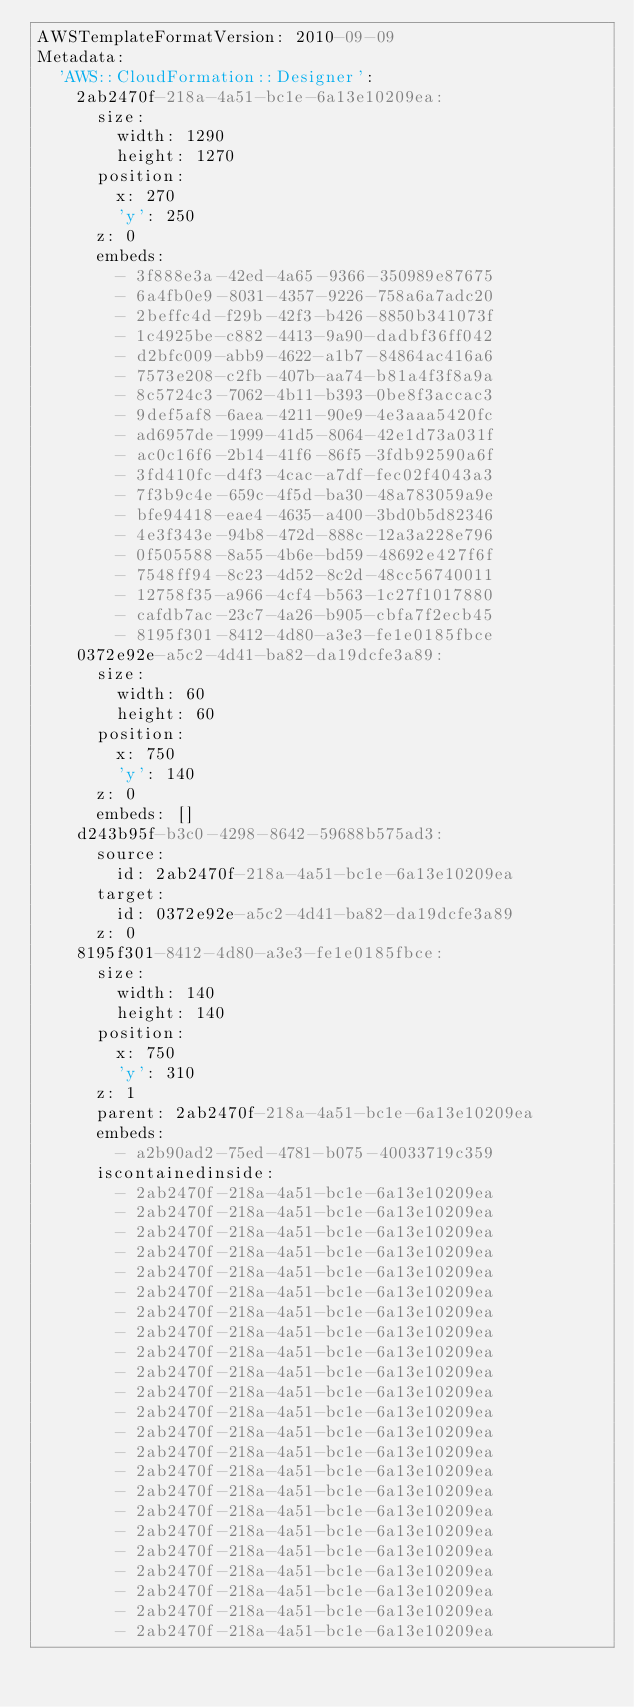Convert code to text. <code><loc_0><loc_0><loc_500><loc_500><_YAML_>AWSTemplateFormatVersion: 2010-09-09
Metadata:
  'AWS::CloudFormation::Designer':
    2ab2470f-218a-4a51-bc1e-6a13e10209ea:
      size:
        width: 1290
        height: 1270
      position:
        x: 270
        'y': 250
      z: 0
      embeds:
        - 3f888e3a-42ed-4a65-9366-350989e87675
        - 6a4fb0e9-8031-4357-9226-758a6a7adc20
        - 2beffc4d-f29b-42f3-b426-8850b341073f
        - 1c4925be-c882-4413-9a90-dadbf36ff042
        - d2bfc009-abb9-4622-a1b7-84864ac416a6
        - 7573e208-c2fb-407b-aa74-b81a4f3f8a9a
        - 8c5724c3-7062-4b11-b393-0be8f3accac3
        - 9def5af8-6aea-4211-90e9-4e3aaa5420fc
        - ad6957de-1999-41d5-8064-42e1d73a031f
        - ac0c16f6-2b14-41f6-86f5-3fdb92590a6f
        - 3fd410fc-d4f3-4cac-a7df-fec02f4043a3
        - 7f3b9c4e-659c-4f5d-ba30-48a783059a9e
        - bfe94418-eae4-4635-a400-3bd0b5d82346
        - 4e3f343e-94b8-472d-888c-12a3a228e796
        - 0f505588-8a55-4b6e-bd59-48692e427f6f
        - 7548ff94-8c23-4d52-8c2d-48cc56740011
        - 12758f35-a966-4cf4-b563-1c27f1017880
        - cafdb7ac-23c7-4a26-b905-cbfa7f2ecb45
        - 8195f301-8412-4d80-a3e3-fe1e0185fbce
    0372e92e-a5c2-4d41-ba82-da19dcfe3a89:
      size:
        width: 60
        height: 60
      position:
        x: 750
        'y': 140
      z: 0
      embeds: []
    d243b95f-b3c0-4298-8642-59688b575ad3:
      source:
        id: 2ab2470f-218a-4a51-bc1e-6a13e10209ea
      target:
        id: 0372e92e-a5c2-4d41-ba82-da19dcfe3a89
      z: 0
    8195f301-8412-4d80-a3e3-fe1e0185fbce:
      size:
        width: 140
        height: 140
      position:
        x: 750
        'y': 310
      z: 1
      parent: 2ab2470f-218a-4a51-bc1e-6a13e10209ea
      embeds:
        - a2b90ad2-75ed-4781-b075-40033719c359
      iscontainedinside:
        - 2ab2470f-218a-4a51-bc1e-6a13e10209ea
        - 2ab2470f-218a-4a51-bc1e-6a13e10209ea
        - 2ab2470f-218a-4a51-bc1e-6a13e10209ea
        - 2ab2470f-218a-4a51-bc1e-6a13e10209ea
        - 2ab2470f-218a-4a51-bc1e-6a13e10209ea
        - 2ab2470f-218a-4a51-bc1e-6a13e10209ea
        - 2ab2470f-218a-4a51-bc1e-6a13e10209ea
        - 2ab2470f-218a-4a51-bc1e-6a13e10209ea
        - 2ab2470f-218a-4a51-bc1e-6a13e10209ea
        - 2ab2470f-218a-4a51-bc1e-6a13e10209ea
        - 2ab2470f-218a-4a51-bc1e-6a13e10209ea
        - 2ab2470f-218a-4a51-bc1e-6a13e10209ea
        - 2ab2470f-218a-4a51-bc1e-6a13e10209ea
        - 2ab2470f-218a-4a51-bc1e-6a13e10209ea
        - 2ab2470f-218a-4a51-bc1e-6a13e10209ea
        - 2ab2470f-218a-4a51-bc1e-6a13e10209ea
        - 2ab2470f-218a-4a51-bc1e-6a13e10209ea
        - 2ab2470f-218a-4a51-bc1e-6a13e10209ea
        - 2ab2470f-218a-4a51-bc1e-6a13e10209ea
        - 2ab2470f-218a-4a51-bc1e-6a13e10209ea
        - 2ab2470f-218a-4a51-bc1e-6a13e10209ea
        - 2ab2470f-218a-4a51-bc1e-6a13e10209ea
        - 2ab2470f-218a-4a51-bc1e-6a13e10209ea</code> 